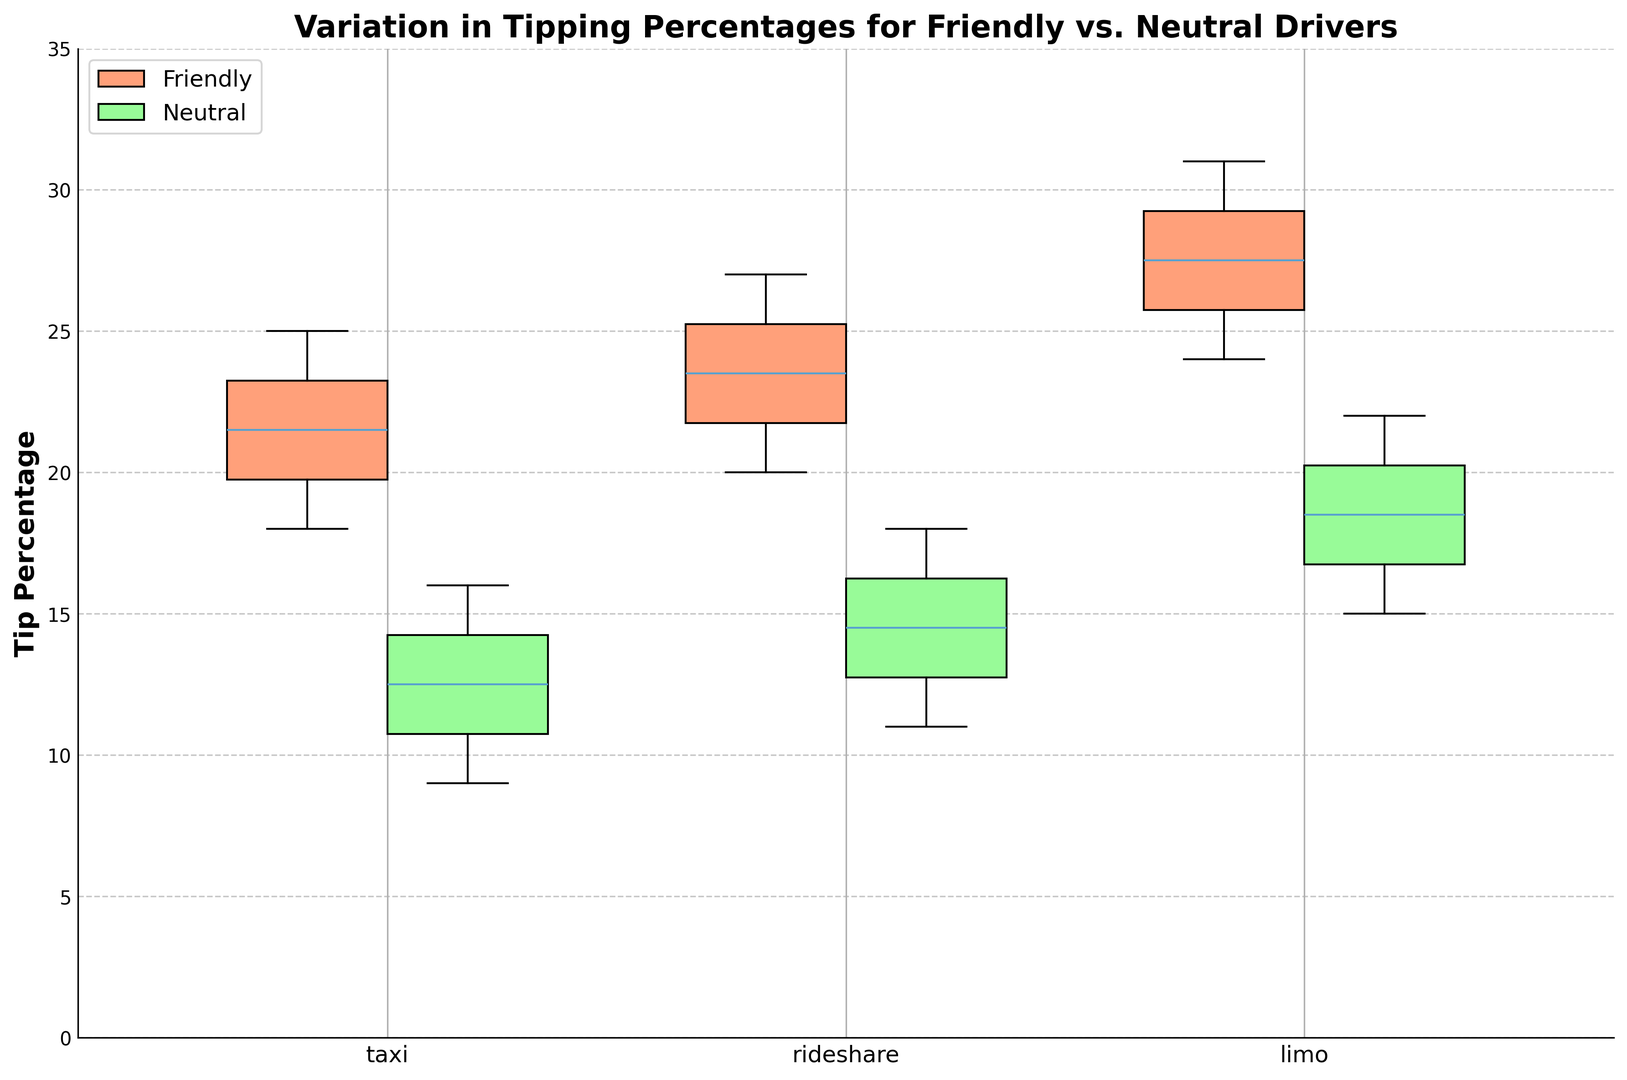What is the median tip percentage for friendly taxi drivers? The box for friendly taxi drivers has a line inside it indicating the median value. By examining the position of this line relative to the y-axis, it can be seen that the median tip percentage for friendly taxi drivers is 21.5%.
Answer: 21.5% Which transportation mode shows the highest tipping percentage for neutral drivers? By looking at the maximum whisker of the box plots for neutral drivers, we see that the limo has the highest tipping percentage. The top whisker for limo's neutral drivers extends to 22%.
Answer: Limo Do friendly rideshare drivers receive higher median tips than neutral rideshare drivers? By comparing the median lines inside the box plots for friendly and neutral rideshare drivers, it is evident that the median line for friendly drivers is higher than that for neutral drivers. The median tip percentage for friendly rideshare drivers is 23.5%, while it is 15% for neutral rideshare drivers.
Answer: Yes What is the interquartile range (IQR) for friendly limo drivers? Interquartile range is calculated by subtracting the first quartile (Q1) from the third quartile (Q3). Visually identifying, the Q3 (top of the box) is approximately 29, and Q1 (bottom of the box) is approximately 25 for friendly limo drivers. So, IQR = 29 - 25 = 4.
Answer: 4 How do the median tip percentages compare between friendly taxi drivers and friendly limo drivers? By examining the box plots, the median line for friendly taxi drivers can be seen around 21.5%, while the median line for friendly limo drivers is around 28%.
Answer: Friendly limo drivers have a higher median tip percentage than friendly taxi drivers Which group has the greatest variation in tipping percentages? Variation can be inferred from the range between the whiskers and the interquartile range (IQR). The neutral limo drivers have the widest spread from the minimum to the maximum (15 to 22), indicating the greatest variation.
Answer: Neutral limo drivers Do friendly drivers receive consistent tips across all transportation modes? Consistency in tips is inferred by the size of each box plot for friendly drivers. Friendly drivers in all modes have relatively consistent tips, but limo drivers demonstrate a slightly more extensive range in their box plot compared to taxi and rideshare.
Answer: Yes, but with slight variation in limos What is the range of tips for neutral rideshare drivers? The range of tips for a group is determined by the highest and lowest whiskers. For neutral rideshare drivers, the maximum whisker is at 18%, and the minimum whisker is at 11%, giving a range of 18 - 11 = 7.
Answer: 7 